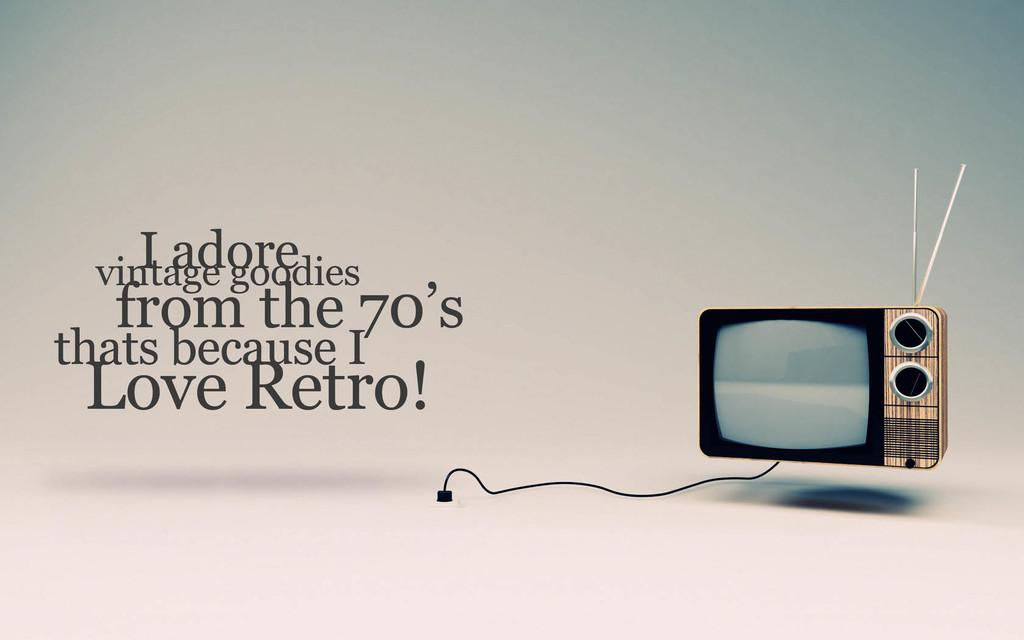<image>
Give a short and clear explanation of the subsequent image. An old style TV is seen in a poster advert saying I love retro form the 70's 